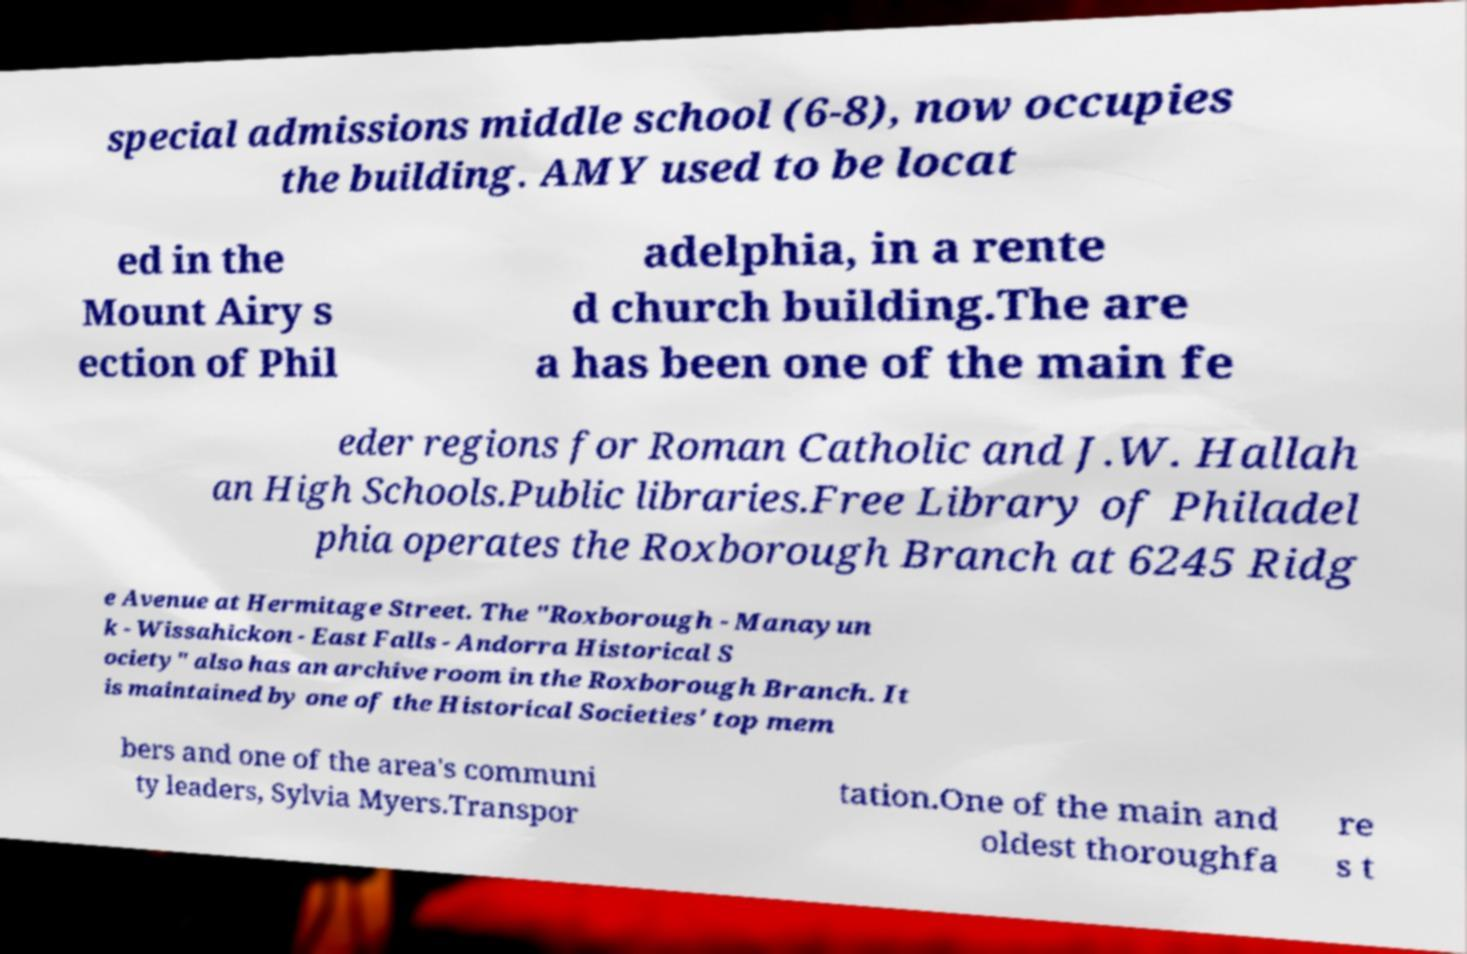Could you assist in decoding the text presented in this image and type it out clearly? special admissions middle school (6-8), now occupies the building. AMY used to be locat ed in the Mount Airy s ection of Phil adelphia, in a rente d church building.The are a has been one of the main fe eder regions for Roman Catholic and J.W. Hallah an High Schools.Public libraries.Free Library of Philadel phia operates the Roxborough Branch at 6245 Ridg e Avenue at Hermitage Street. The "Roxborough - Manayun k - Wissahickon - East Falls - Andorra Historical S ociety" also has an archive room in the Roxborough Branch. It is maintained by one of the Historical Societies' top mem bers and one of the area's communi ty leaders, Sylvia Myers.Transpor tation.One of the main and oldest thoroughfa re s t 